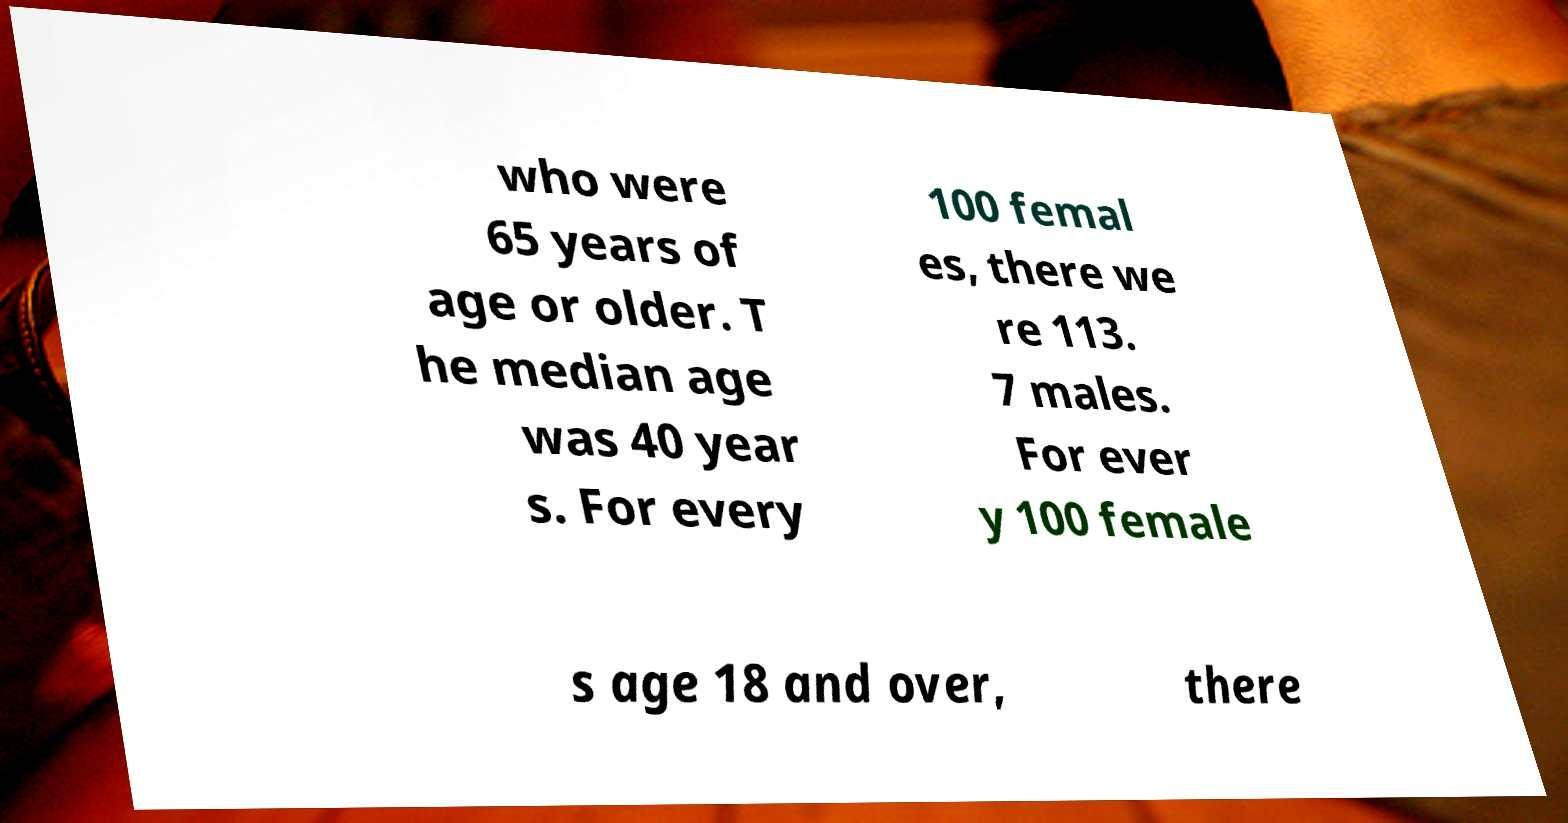Could you assist in decoding the text presented in this image and type it out clearly? who were 65 years of age or older. T he median age was 40 year s. For every 100 femal es, there we re 113. 7 males. For ever y 100 female s age 18 and over, there 